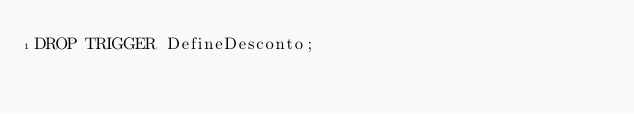Convert code to text. <code><loc_0><loc_0><loc_500><loc_500><_SQL_>DROP TRIGGER DefineDesconto;</code> 